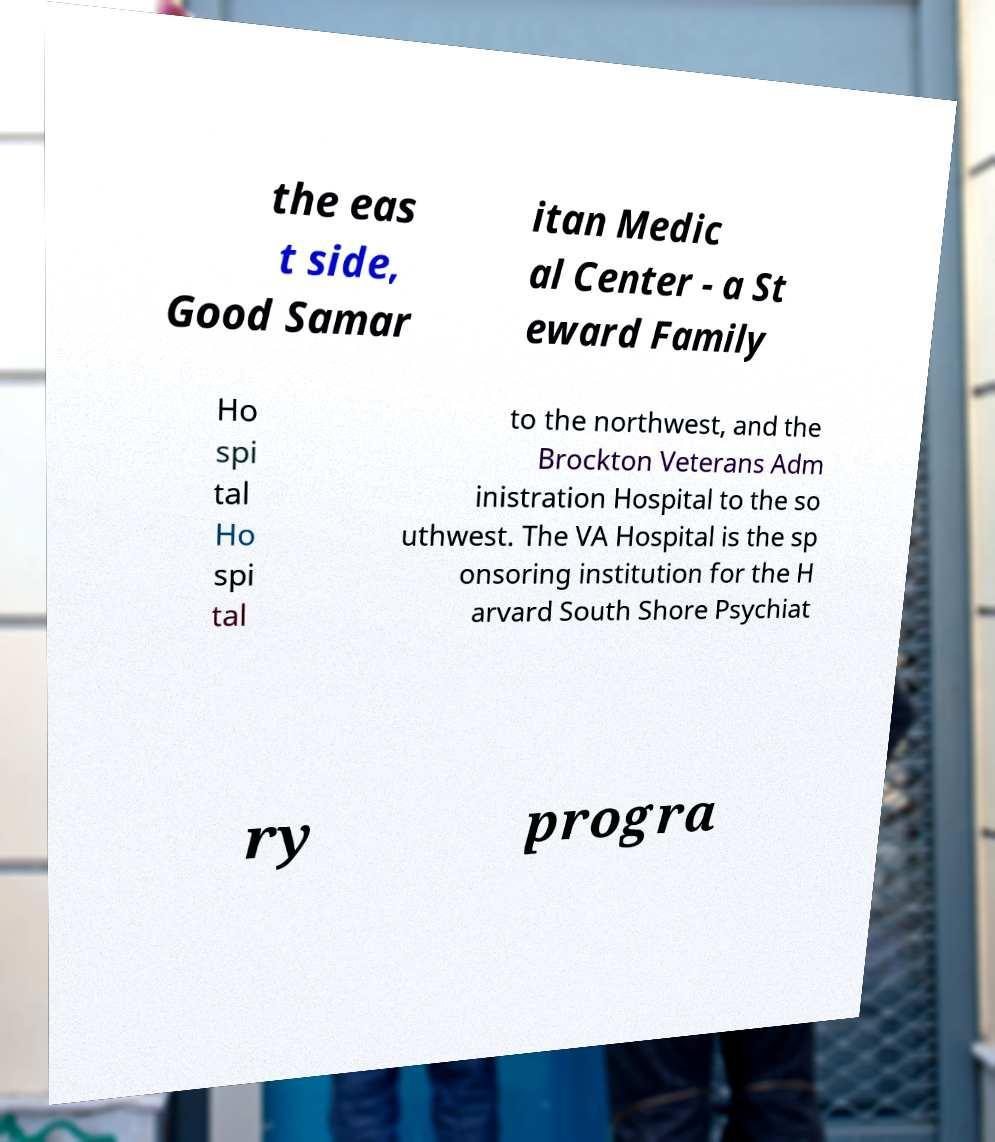I need the written content from this picture converted into text. Can you do that? the eas t side, Good Samar itan Medic al Center - a St eward Family Ho spi tal Ho spi tal to the northwest, and the Brockton Veterans Adm inistration Hospital to the so uthwest. The VA Hospital is the sp onsoring institution for the H arvard South Shore Psychiat ry progra 